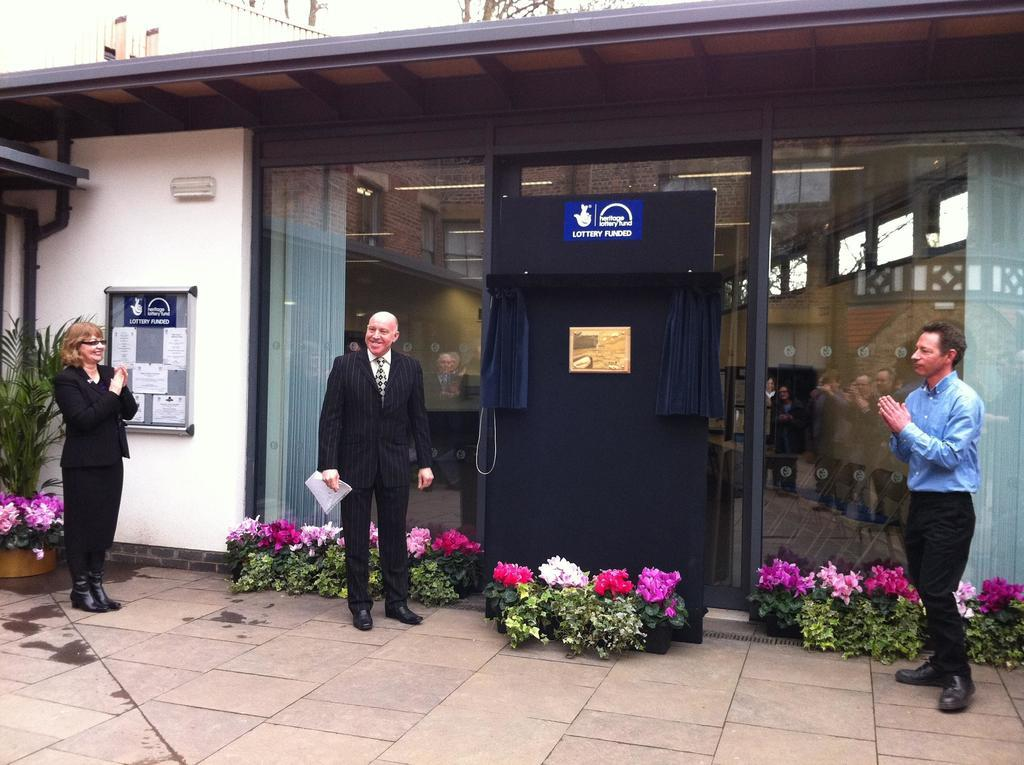<image>
Summarize the visual content of the image. heritage lotter funded fron of the office building 